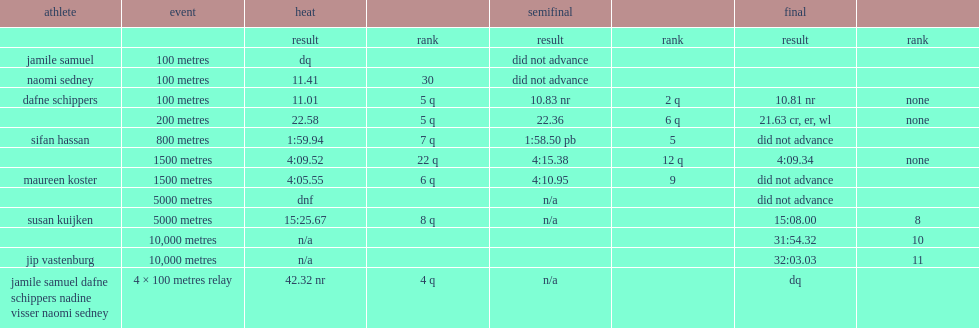What is the final result for dafne schippers? 10.81 nr. 